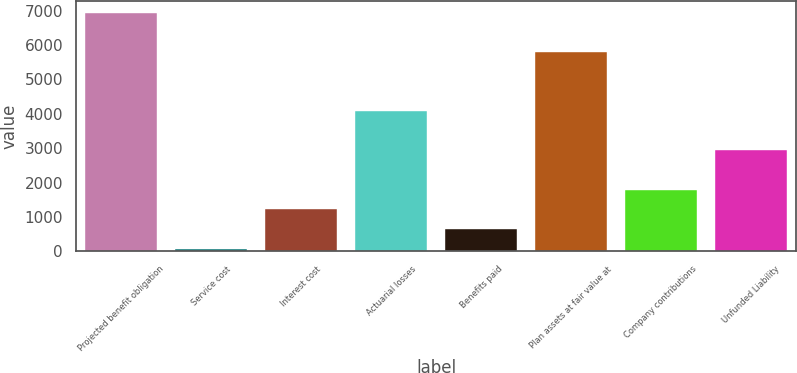Convert chart. <chart><loc_0><loc_0><loc_500><loc_500><bar_chart><fcel>Projected benefit obligation<fcel>Service cost<fcel>Interest cost<fcel>Actuarial losses<fcel>Benefits paid<fcel>Plan assets at fair value at<fcel>Company contributions<fcel>Unfunded Liability<nl><fcel>6940.4<fcel>86<fcel>1228.4<fcel>4084.4<fcel>657.2<fcel>5798<fcel>1799.6<fcel>2942<nl></chart> 